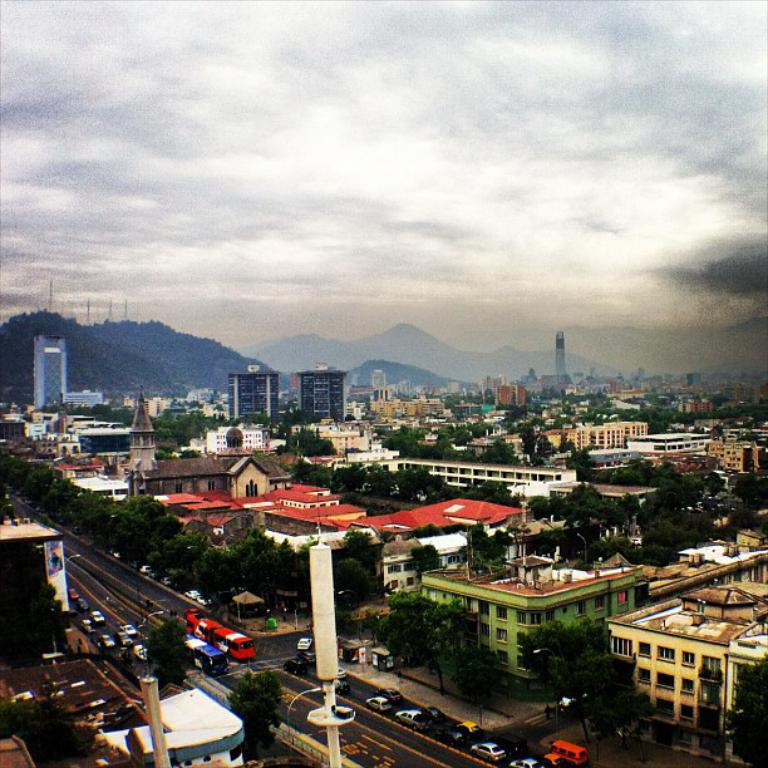What type of location might the image be taken in? The image might be taken in the city, based on the presence of buildings, roads, and vehicles. Can you describe the structures visible in the image? There are buildings, hills, and trees visible in the image. What type of transportation can be seen in the image? Cars and other vehicles are present in the image. What is visible in the background of the image? The sky, clouds, and poles are visible in the background of the image. What type of surprise can be seen in the image? There is no surprise present in the image; it features a cityscape with buildings, hills, trees, cars, roads, and poles. What type of glass object can be seen in the image? There is no glass object present in the image. 